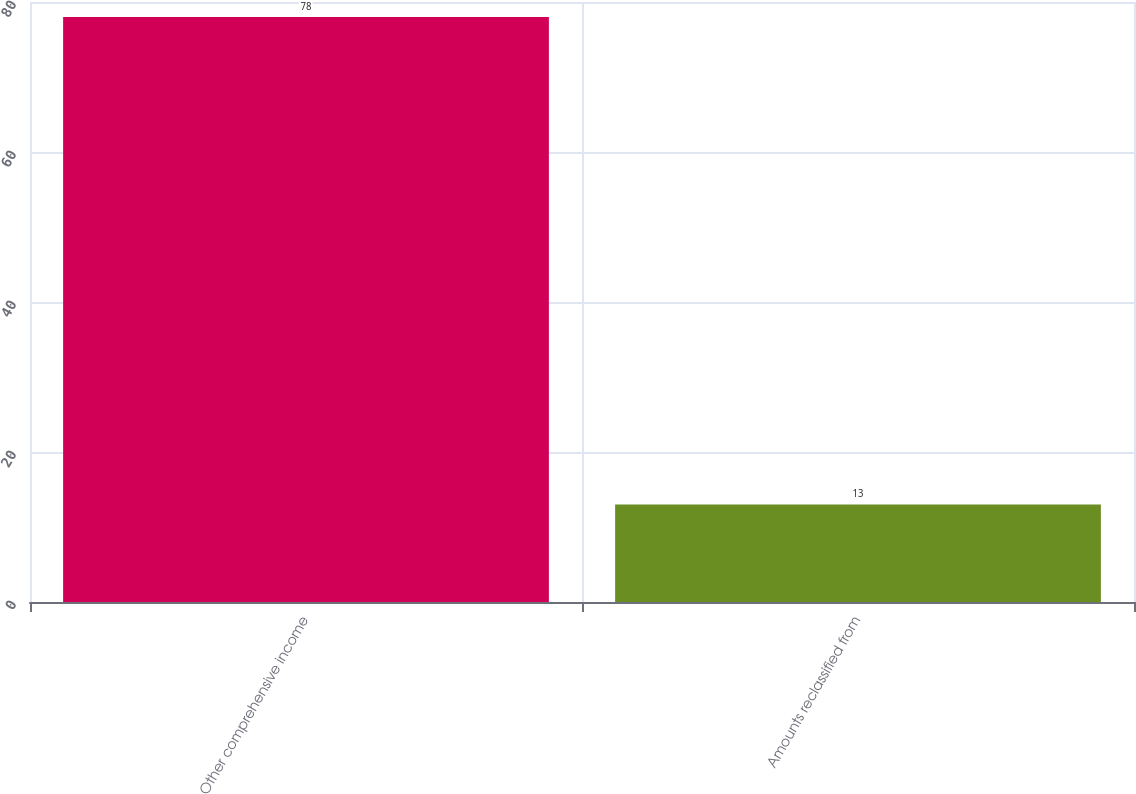Convert chart to OTSL. <chart><loc_0><loc_0><loc_500><loc_500><bar_chart><fcel>Other comprehensive income<fcel>Amounts reclassified from<nl><fcel>78<fcel>13<nl></chart> 